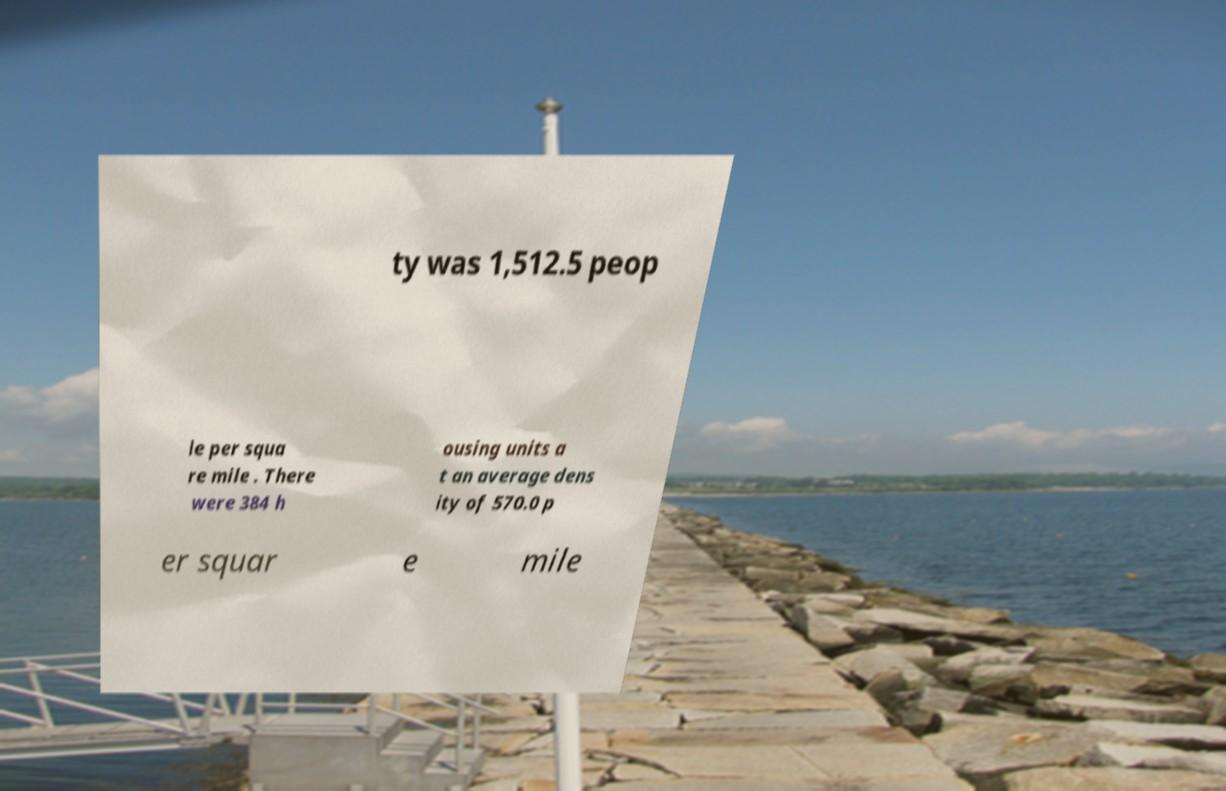Can you read and provide the text displayed in the image?This photo seems to have some interesting text. Can you extract and type it out for me? ty was 1,512.5 peop le per squa re mile . There were 384 h ousing units a t an average dens ity of 570.0 p er squar e mile 